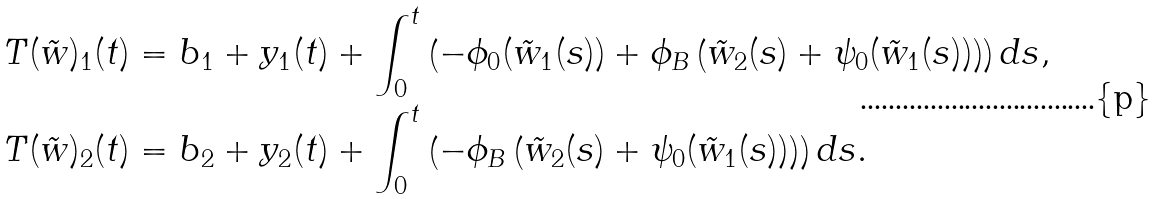<formula> <loc_0><loc_0><loc_500><loc_500>T ( \tilde { w } ) _ { 1 } ( t ) & = b _ { 1 } + y _ { 1 } ( t ) + \int _ { 0 } ^ { t } \left ( - \phi _ { 0 } ( \tilde { w } _ { 1 } ( s ) ) + \phi _ { B } \left ( \tilde { w } _ { 2 } ( s ) + \psi _ { 0 } ( \tilde { w } _ { 1 } ( s ) ) \right ) \right ) d s , \\ T ( \tilde { w } ) _ { 2 } ( t ) & = b _ { 2 } + y _ { 2 } ( t ) + \int _ { 0 } ^ { t } \left ( - \phi _ { B } \left ( \tilde { w } _ { 2 } ( s ) + \psi _ { 0 } ( \tilde { w } _ { 1 } ( s ) ) \right ) \right ) d s .</formula> 